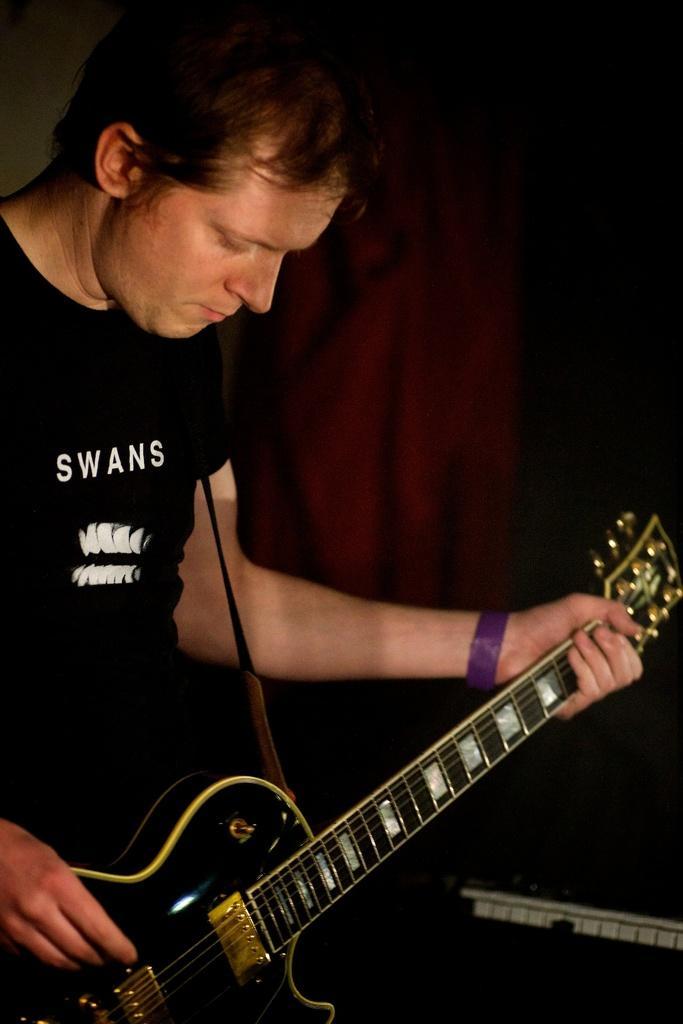Please provide a concise description of this image. As we can see in the image, there is a man holding guitar. 